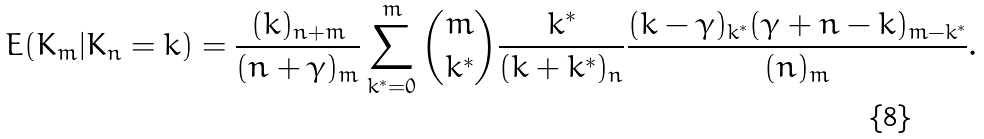<formula> <loc_0><loc_0><loc_500><loc_500>E ( K _ { m } | K _ { n } = k ) = \frac { ( k ) _ { n + m } } { ( n + \gamma ) _ { m } } \sum _ { k ^ { * } = 0 } ^ { m } { m \choose k ^ { * } } \frac { k ^ { * } } { ( k + k ^ { * } ) _ { n } } \frac { ( k - \gamma ) _ { k ^ { * } } ( \gamma + n - k ) _ { m - k ^ { * } } } { ( n ) _ { m } } .</formula> 